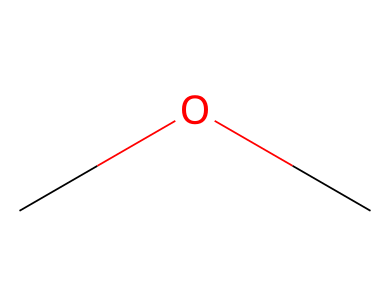What is the name of this chemical? The SMILES representation "COC" indicates a molecule made up of two carbon atoms connected by an ether bond to an oxygen atom. This structure corresponds to dimethyl ether.
Answer: dimethyl ether How many carbon atoms are present? In the SMILES representation "COC", there are two 'C' symbols, each representing a carbon atom. Thus, the total number of carbon atoms is two.
Answer: 2 What type of chemical compound is represented? The presence of a carbon-oxygen single bond and the structure of "COC" categorizes this compound as an ether, which is characterized by the R-O-R' structure where R and R' are alkyl or aryl groups.
Answer: ether What functional group is found in this chemical? The "O" in the SMILES "COC" indicates the presence of an ether functional group, as it comprises an oxygen atom connecting two carbon atoms.
Answer: ether What is the molecular formula of this compound? By analyzing the components represented in the SMILES "COC", we count the atoms: there are 2 carbons (C), 6 hydrogens (H), and 1 oxygen (O), leading to the molecular formula C2H6O.
Answer: C2H6O What is the bond order between the carbon and oxygen atoms? The bond between the carbon and oxygen in the ether "COC" represents a single bond, which has a bond order of 1. Specifically, each carbon atom is connected to the oxygen by a single covalent bond.
Answer: 1 What physical state is dimethyl ether at room temperature? Dimethyl ether is known to be a gas at room temperature due to its low molecular weight and soft intermolecular forces, resulting in low boiling and melting points.
Answer: gas 